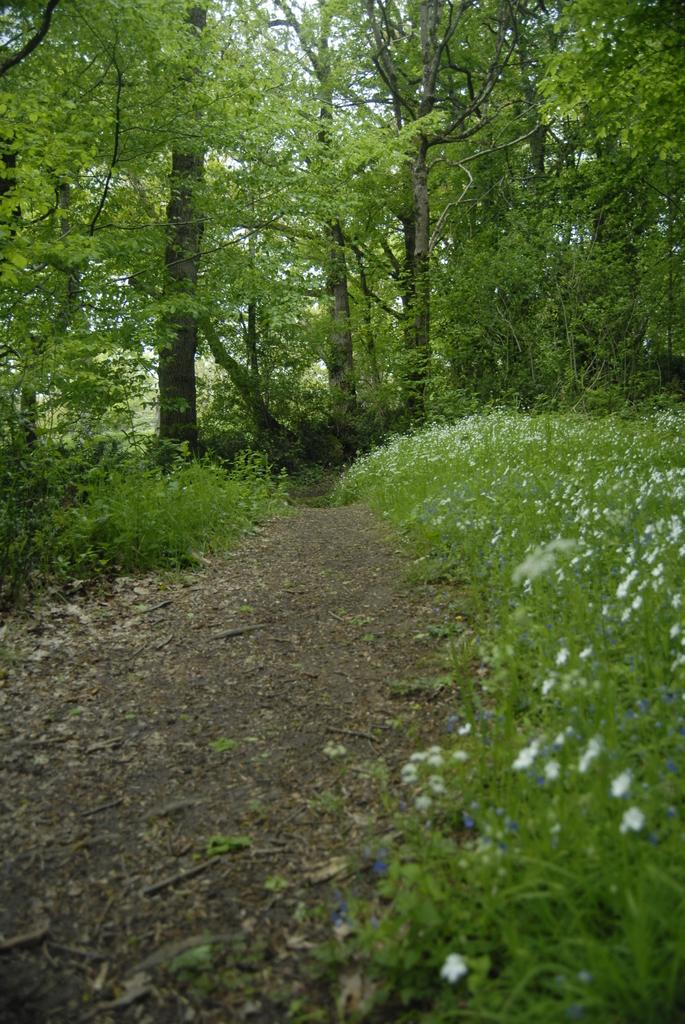What can be seen in the image that people might walk on? There is a path in the image that people might walk on. What type of vegetation is present alongside the path? Small plants are present on either side of the path. What can be seen in the distance in the image? There are trees in the background of the image. What is visible above the trees in the image? The sky is visible in the background of the image. What type of toothpaste is used to clean the path in the image? There is no toothpaste present in the image, and the path does not need to be cleaned. 